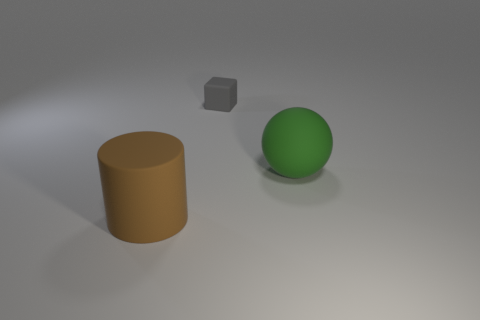Is there anything else that is the same size as the gray block?
Ensure brevity in your answer.  No. Are there any other things that have the same shape as the tiny gray rubber object?
Ensure brevity in your answer.  No. How many things are green rubber balls or big things behind the big brown matte thing?
Your response must be concise. 1. Is the thing that is in front of the large green ball made of the same material as the thing behind the green object?
Provide a short and direct response. Yes. What number of brown things are either big rubber cylinders or cubes?
Keep it short and to the point. 1. What is the size of the green sphere?
Keep it short and to the point. Large. Is the number of small matte objects that are to the right of the small gray block greater than the number of green cylinders?
Provide a short and direct response. No. There is a brown thing; how many big things are right of it?
Your answer should be compact. 1. Are there any yellow balls of the same size as the brown thing?
Give a very brief answer. No. There is a thing to the right of the gray rubber cube; is its size the same as the object that is behind the ball?
Ensure brevity in your answer.  No. 